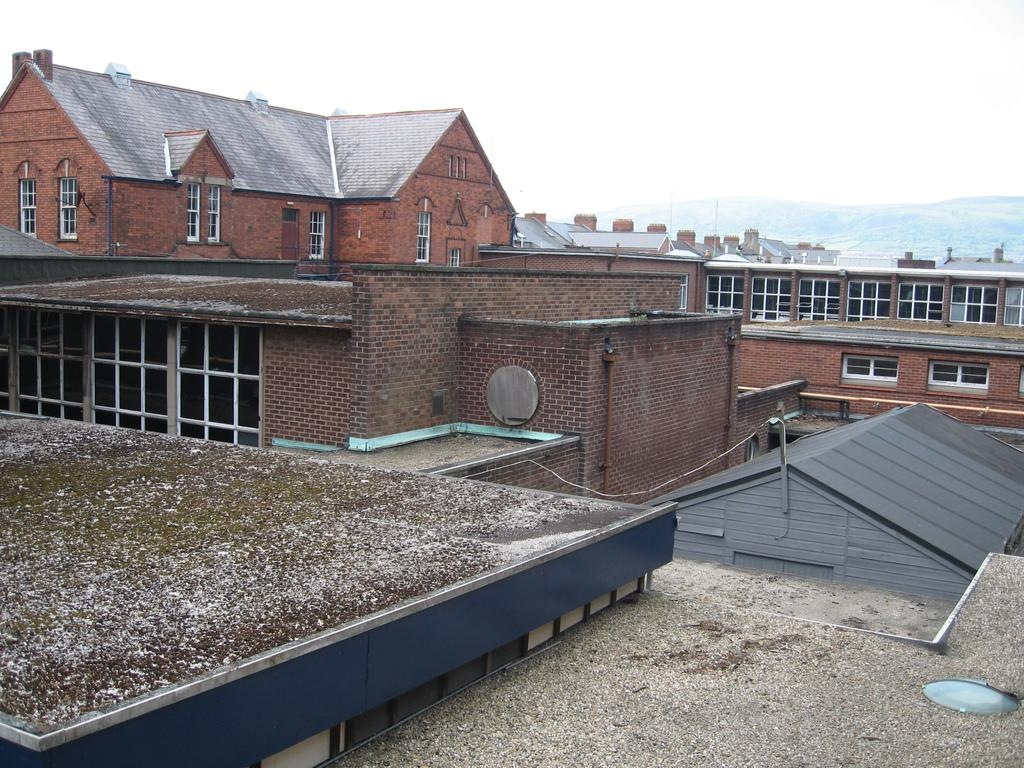What type of structures can be seen in the image? There are buildings in the image. What feature is visible on the buildings? There are windows visible in the image. What natural feature is present in the image? There is a hill in the image. What is visible in the background of the image? The sky is visible in the image. What type of nut is being used to create the scene in the image? There is no nut present in the image, and no scene is being created with nuts. 